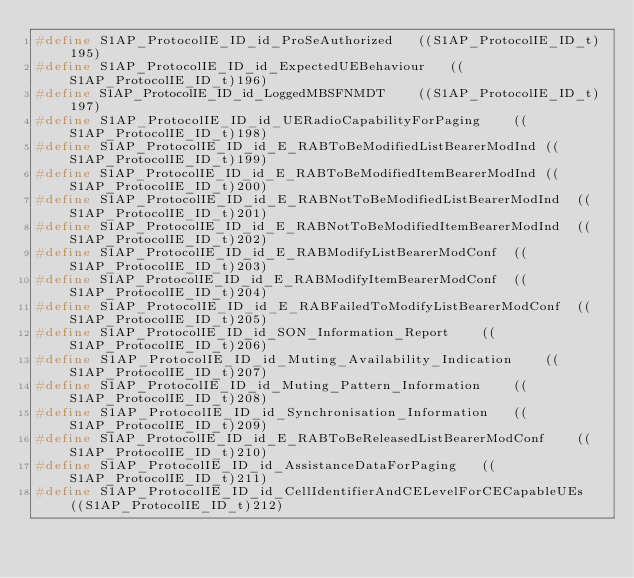Convert code to text. <code><loc_0><loc_0><loc_500><loc_500><_C_>#define S1AP_ProtocolIE_ID_id_ProSeAuthorized	((S1AP_ProtocolIE_ID_t)195)
#define S1AP_ProtocolIE_ID_id_ExpectedUEBehaviour	((S1AP_ProtocolIE_ID_t)196)
#define S1AP_ProtocolIE_ID_id_LoggedMBSFNMDT	((S1AP_ProtocolIE_ID_t)197)
#define S1AP_ProtocolIE_ID_id_UERadioCapabilityForPaging	((S1AP_ProtocolIE_ID_t)198)
#define S1AP_ProtocolIE_ID_id_E_RABToBeModifiedListBearerModInd	((S1AP_ProtocolIE_ID_t)199)
#define S1AP_ProtocolIE_ID_id_E_RABToBeModifiedItemBearerModInd	((S1AP_ProtocolIE_ID_t)200)
#define S1AP_ProtocolIE_ID_id_E_RABNotToBeModifiedListBearerModInd	((S1AP_ProtocolIE_ID_t)201)
#define S1AP_ProtocolIE_ID_id_E_RABNotToBeModifiedItemBearerModInd	((S1AP_ProtocolIE_ID_t)202)
#define S1AP_ProtocolIE_ID_id_E_RABModifyListBearerModConf	((S1AP_ProtocolIE_ID_t)203)
#define S1AP_ProtocolIE_ID_id_E_RABModifyItemBearerModConf	((S1AP_ProtocolIE_ID_t)204)
#define S1AP_ProtocolIE_ID_id_E_RABFailedToModifyListBearerModConf	((S1AP_ProtocolIE_ID_t)205)
#define S1AP_ProtocolIE_ID_id_SON_Information_Report	((S1AP_ProtocolIE_ID_t)206)
#define S1AP_ProtocolIE_ID_id_Muting_Availability_Indication	((S1AP_ProtocolIE_ID_t)207)
#define S1AP_ProtocolIE_ID_id_Muting_Pattern_Information	((S1AP_ProtocolIE_ID_t)208)
#define S1AP_ProtocolIE_ID_id_Synchronisation_Information	((S1AP_ProtocolIE_ID_t)209)
#define S1AP_ProtocolIE_ID_id_E_RABToBeReleasedListBearerModConf	((S1AP_ProtocolIE_ID_t)210)
#define S1AP_ProtocolIE_ID_id_AssistanceDataForPaging	((S1AP_ProtocolIE_ID_t)211)
#define S1AP_ProtocolIE_ID_id_CellIdentifierAndCELevelForCECapableUEs	((S1AP_ProtocolIE_ID_t)212)</code> 